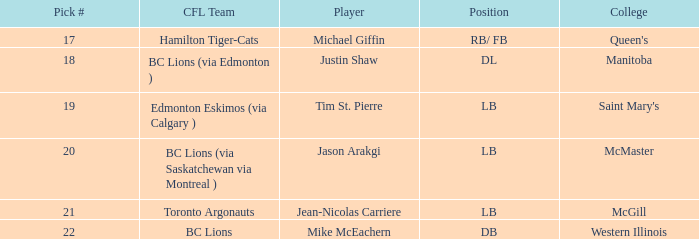What college does Jean-Nicolas Carriere play for? McGill. 